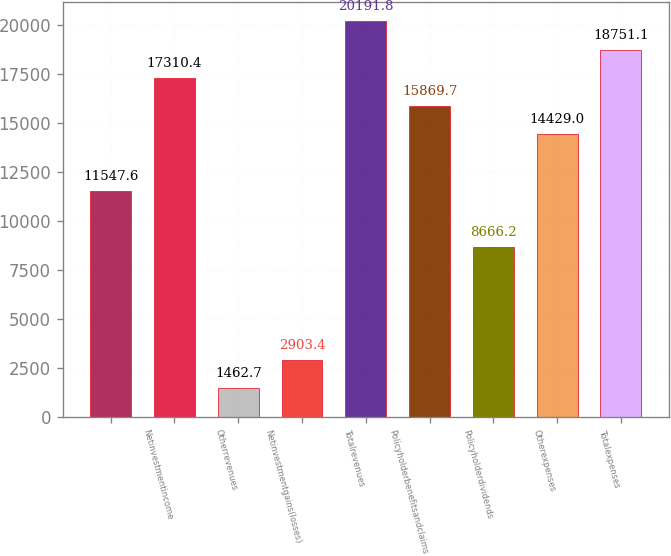Convert chart to OTSL. <chart><loc_0><loc_0><loc_500><loc_500><bar_chart><ecel><fcel>Netinvestmentincome<fcel>Otherrevenues<fcel>Netinvestmentgains(losses)<fcel>Totalrevenues<fcel>Policyholderbenefitsandclaims<fcel>Policyholderdividends<fcel>Otherexpenses<fcel>Totalexpenses<nl><fcel>11547.6<fcel>17310.4<fcel>1462.7<fcel>2903.4<fcel>20191.8<fcel>15869.7<fcel>8666.2<fcel>14429<fcel>18751.1<nl></chart> 